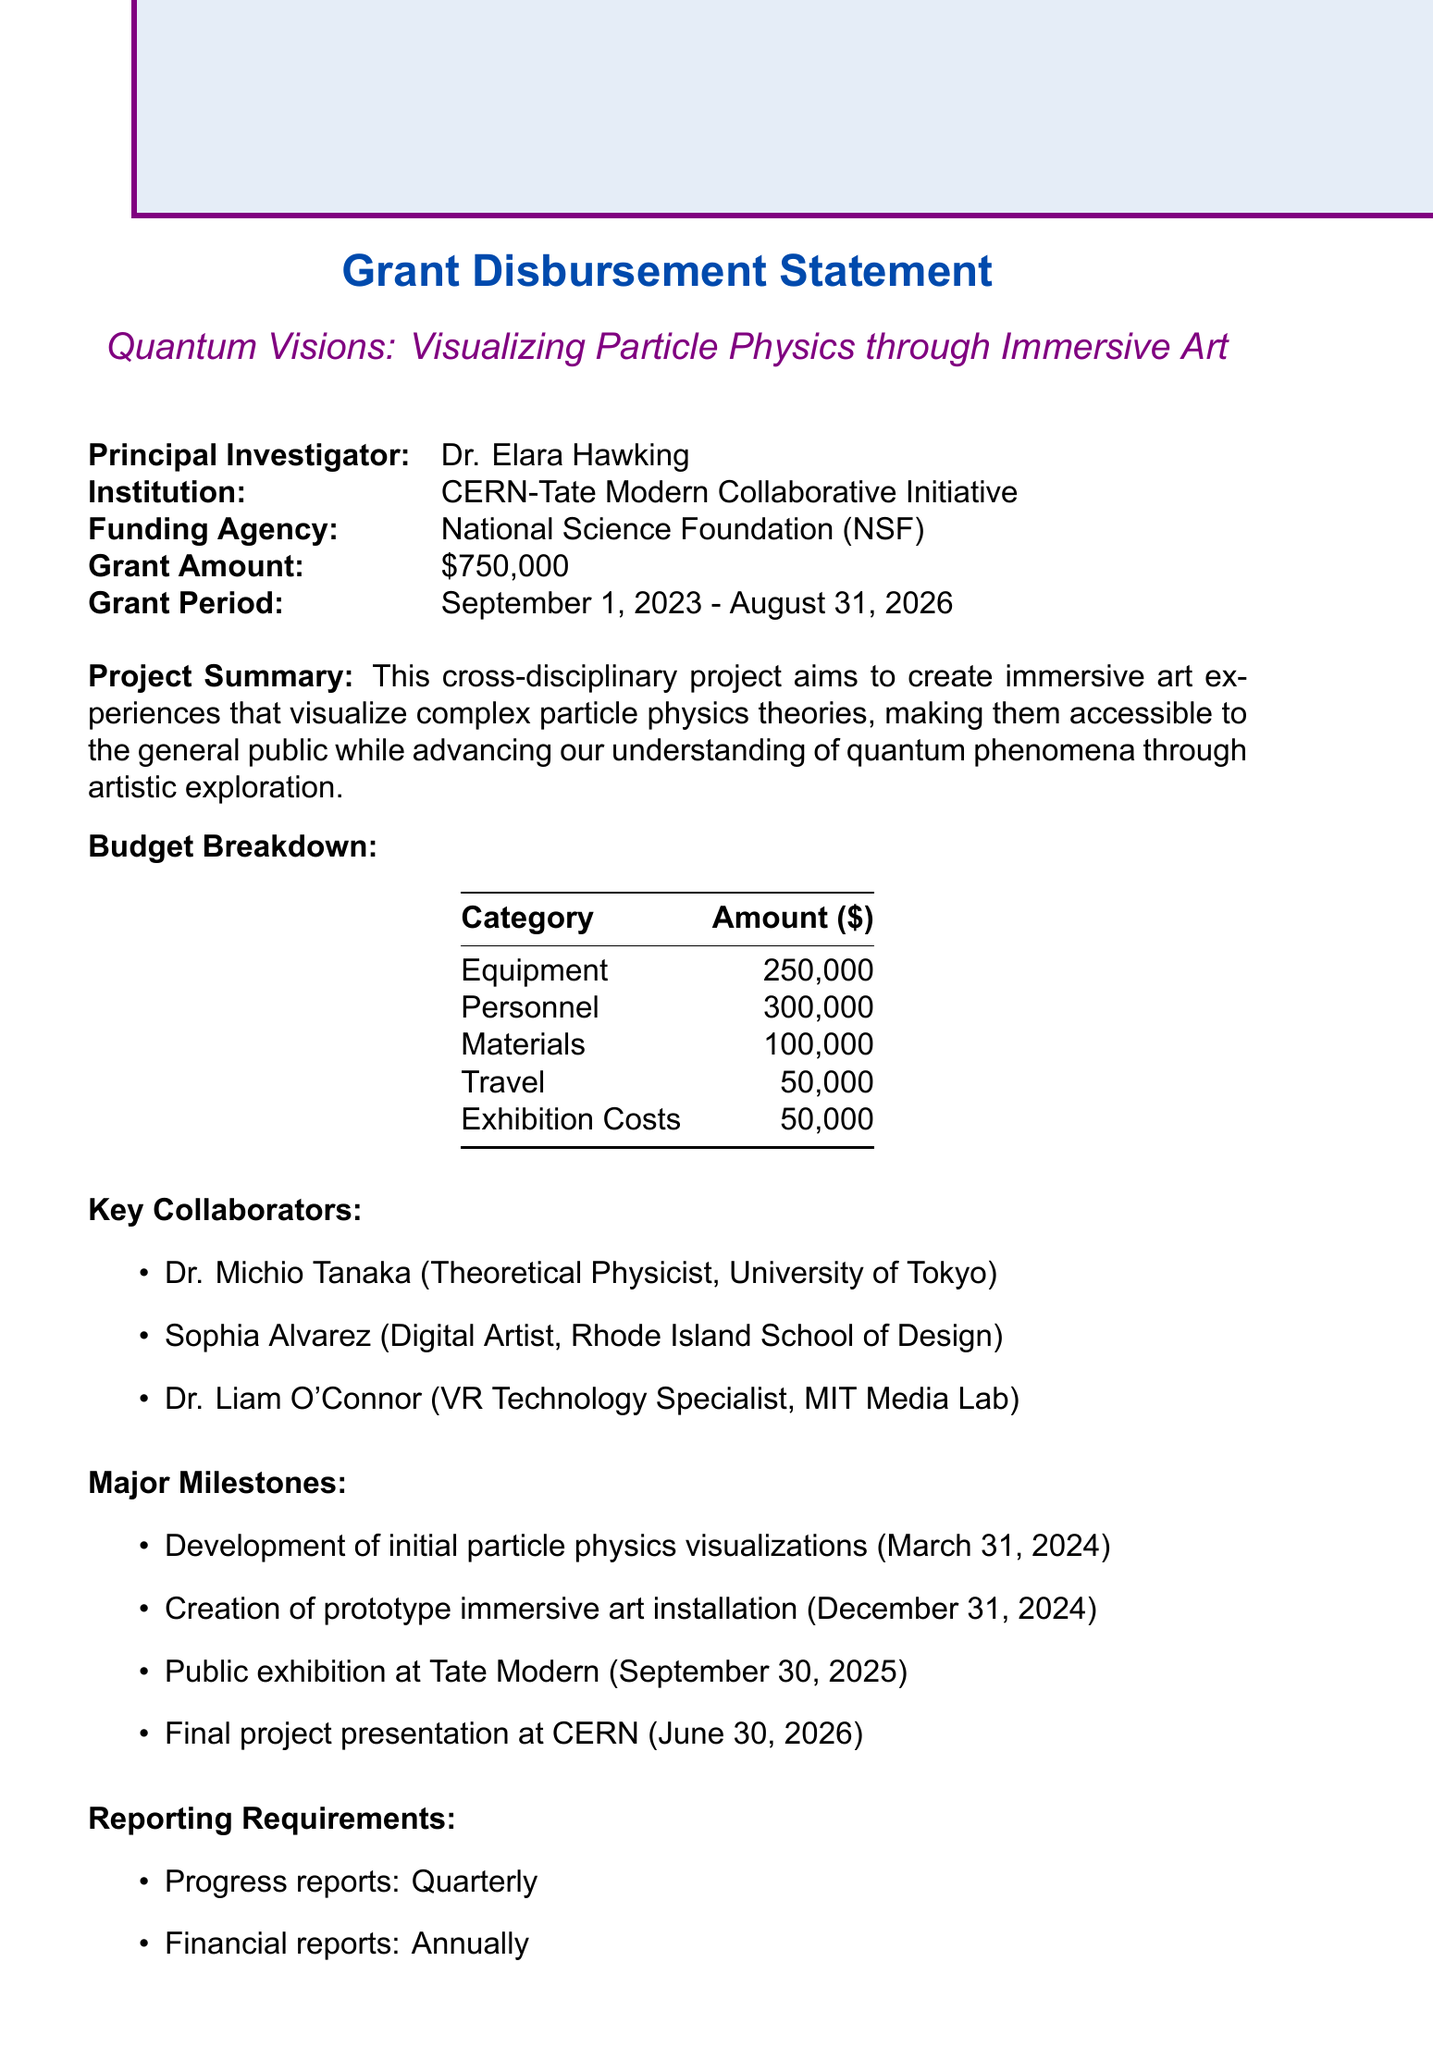What is the project title? The project title is prominently mentioned at the beginning of the document.
Answer: Quantum Visions: Visualizing Particle Physics through Immersive Art Who is the principal investigator? The document lists the principal investigator under key details.
Answer: Dr. Elara Hawking What is the total grant amount? The total grant amount is stated in the financial summary of the document.
Answer: $750,000 What is the start date of the grant period? The grant period's start date is explicitly mentioned.
Answer: September 1, 2023 How much is allocated for personnel? The budget breakdown specifies the allocation for personnel.
Answer: $300,000 What is one of the anticipated outcomes? Anticipated outcomes are listed as benefits expected from the project.
Answer: Novel visualization techniques for complex quantum phenomena Who is collaborating as a digital artist? A section for key collaborators includes the digital artist's name and institution.
Answer: Sophia Alvarez What type of reports are required quarterly? The reporting requirements section indicates the frequency of certain reports.
Answer: Progress reports What is the due date for the final report? The final report due date is mentioned in the reporting requirements.
Answer: October 31, 2026 